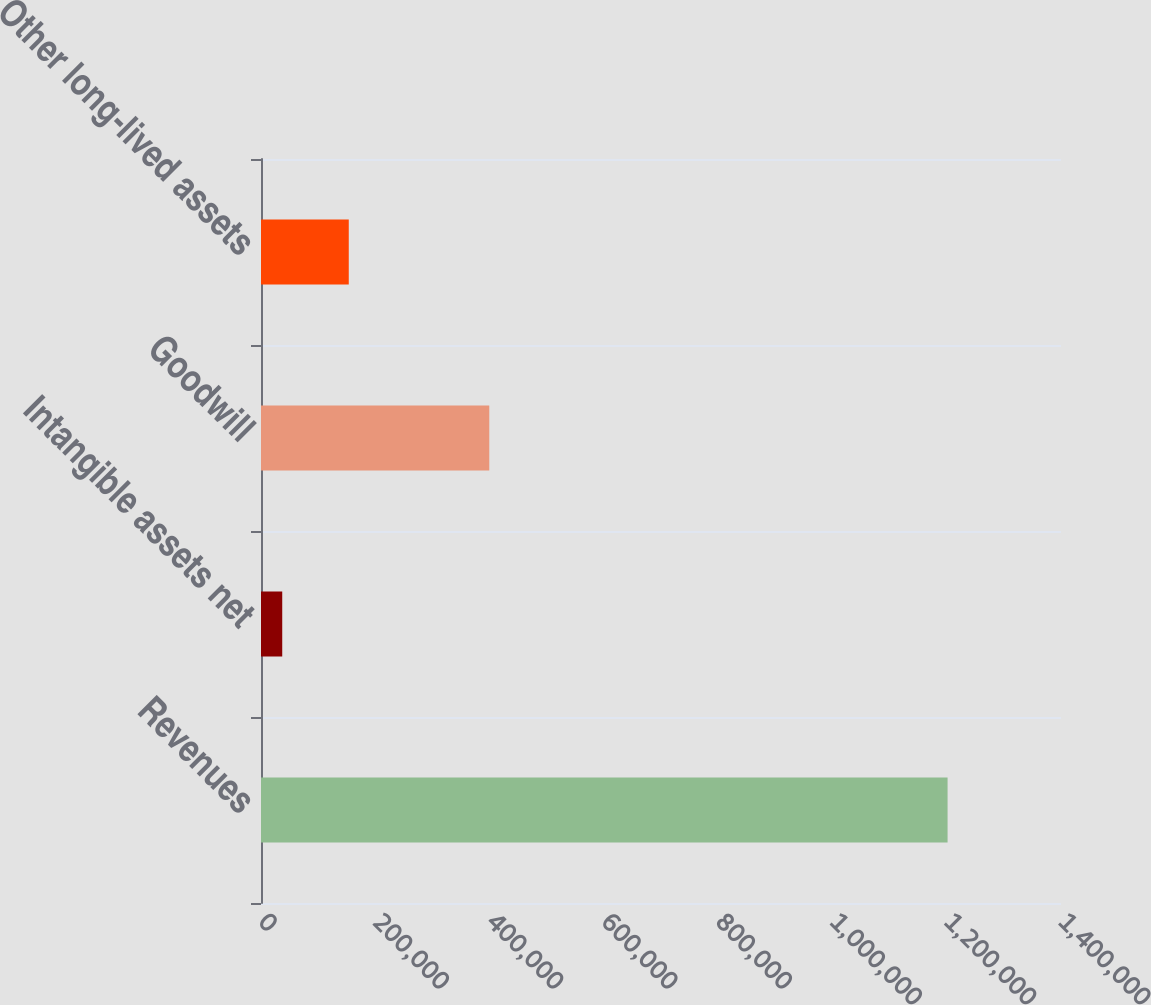<chart> <loc_0><loc_0><loc_500><loc_500><bar_chart><fcel>Revenues<fcel>Intangible assets net<fcel>Goodwill<fcel>Other long-lived assets<nl><fcel>1.20151e+06<fcel>37155<fcel>399483<fcel>153591<nl></chart> 